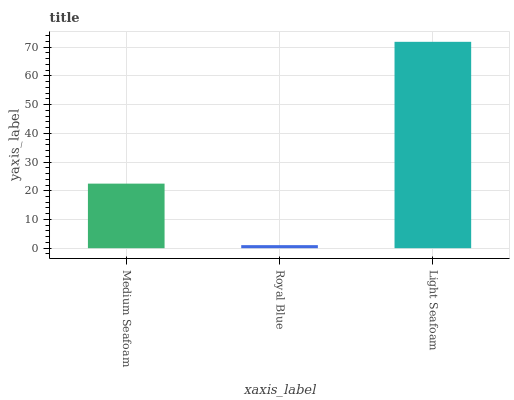Is Light Seafoam the minimum?
Answer yes or no. No. Is Royal Blue the maximum?
Answer yes or no. No. Is Light Seafoam greater than Royal Blue?
Answer yes or no. Yes. Is Royal Blue less than Light Seafoam?
Answer yes or no. Yes. Is Royal Blue greater than Light Seafoam?
Answer yes or no. No. Is Light Seafoam less than Royal Blue?
Answer yes or no. No. Is Medium Seafoam the high median?
Answer yes or no. Yes. Is Medium Seafoam the low median?
Answer yes or no. Yes. Is Royal Blue the high median?
Answer yes or no. No. Is Light Seafoam the low median?
Answer yes or no. No. 